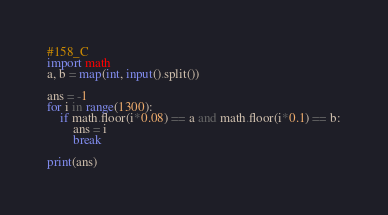Convert code to text. <code><loc_0><loc_0><loc_500><loc_500><_Python_>#158_C
import math
a, b = map(int, input().split())

ans = -1
for i in range(1300):
    if math.floor(i*0.08) == a and math.floor(i*0.1) == b:
        ans = i
        break

print(ans)</code> 